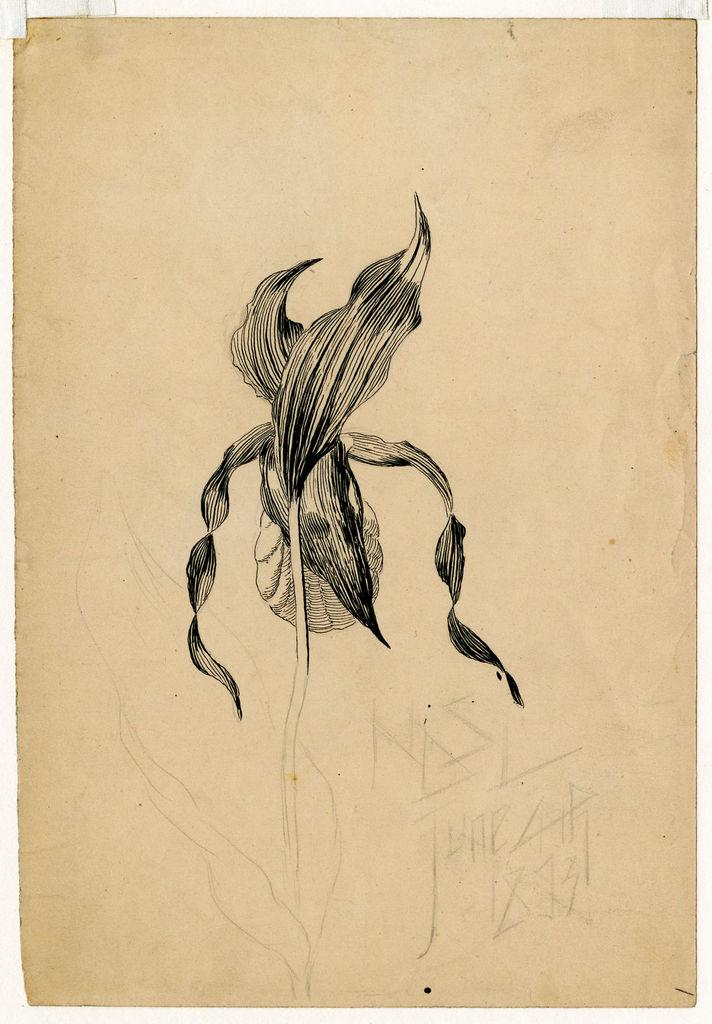What is depicted in the painting in the image? There is a painting of a plant with leaves in the image. Where is the painting located in the image? The painting is in the middle of the image. What other artwork is visible in the image? There is a drawing beside the painting. What type of jeans is the plant wearing in the image? There are no jeans present in the image, as the subject is a painting of a plant with leaves. 